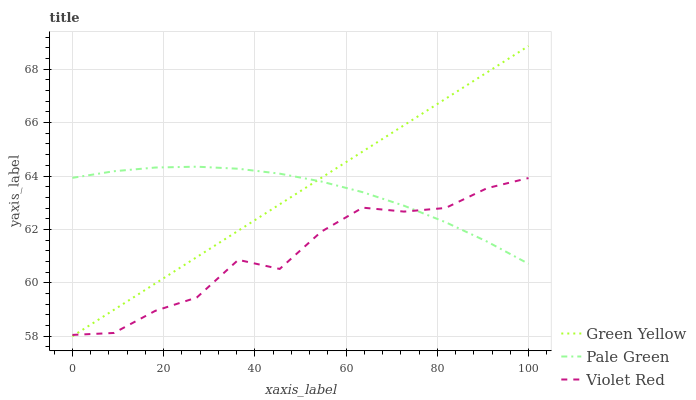Does Violet Red have the minimum area under the curve?
Answer yes or no. Yes. Does Green Yellow have the maximum area under the curve?
Answer yes or no. Yes. Does Green Yellow have the minimum area under the curve?
Answer yes or no. No. Does Violet Red have the maximum area under the curve?
Answer yes or no. No. Is Green Yellow the smoothest?
Answer yes or no. Yes. Is Violet Red the roughest?
Answer yes or no. Yes. Is Violet Red the smoothest?
Answer yes or no. No. Is Green Yellow the roughest?
Answer yes or no. No. Does Green Yellow have the lowest value?
Answer yes or no. Yes. Does Violet Red have the lowest value?
Answer yes or no. No. Does Green Yellow have the highest value?
Answer yes or no. Yes. Does Violet Red have the highest value?
Answer yes or no. No. Does Green Yellow intersect Pale Green?
Answer yes or no. Yes. Is Green Yellow less than Pale Green?
Answer yes or no. No. Is Green Yellow greater than Pale Green?
Answer yes or no. No. 